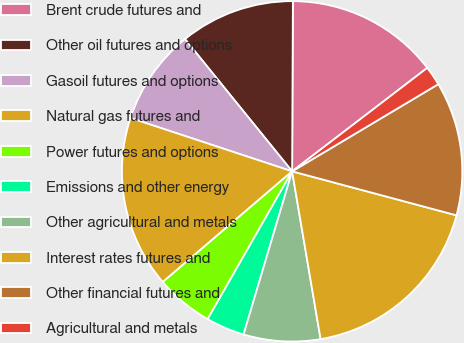Convert chart. <chart><loc_0><loc_0><loc_500><loc_500><pie_chart><fcel>Brent crude futures and<fcel>Other oil futures and options<fcel>Gasoil futures and options<fcel>Natural gas futures and<fcel>Power futures and options<fcel>Emissions and other energy<fcel>Other agricultural and metals<fcel>Interest rates futures and<fcel>Other financial futures and<fcel>Agricultural and metals<nl><fcel>14.53%<fcel>10.91%<fcel>9.09%<fcel>16.34%<fcel>5.47%<fcel>3.66%<fcel>7.28%<fcel>18.16%<fcel>12.72%<fcel>1.84%<nl></chart> 